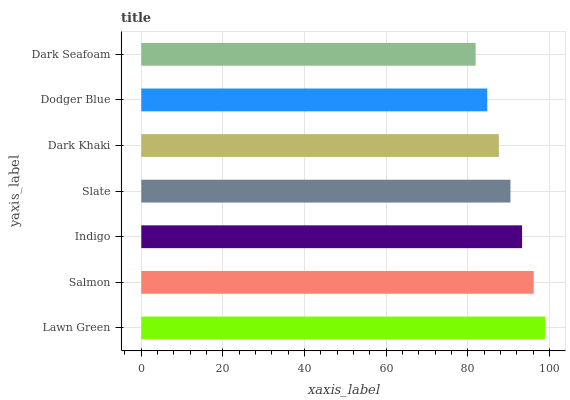Is Dark Seafoam the minimum?
Answer yes or no. Yes. Is Lawn Green the maximum?
Answer yes or no. Yes. Is Salmon the minimum?
Answer yes or no. No. Is Salmon the maximum?
Answer yes or no. No. Is Lawn Green greater than Salmon?
Answer yes or no. Yes. Is Salmon less than Lawn Green?
Answer yes or no. Yes. Is Salmon greater than Lawn Green?
Answer yes or no. No. Is Lawn Green less than Salmon?
Answer yes or no. No. Is Slate the high median?
Answer yes or no. Yes. Is Slate the low median?
Answer yes or no. Yes. Is Dodger Blue the high median?
Answer yes or no. No. Is Dark Seafoam the low median?
Answer yes or no. No. 